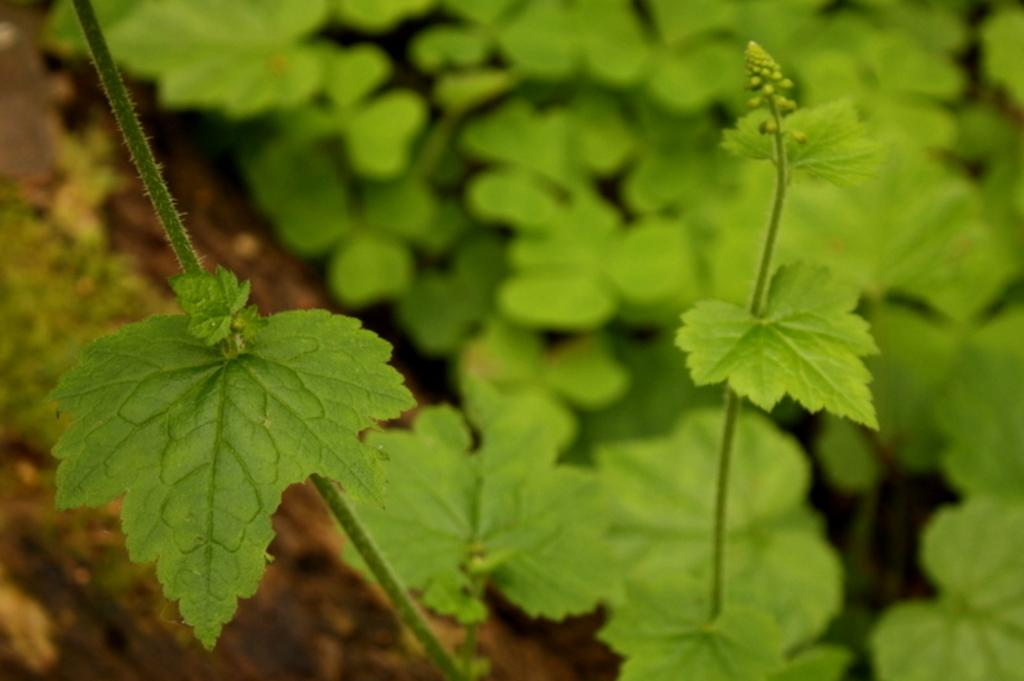What type of vegetation is present in the image? There are green leaves in the image. How are the green leaves depicted in the image? The green leaves are blurred in the background of the image. What type of industry is depicted in the image? There is no industry depicted in the image; it features green leaves in the background. What time of day is it in the image? The provided facts do not give any information about the time of day in the image. 